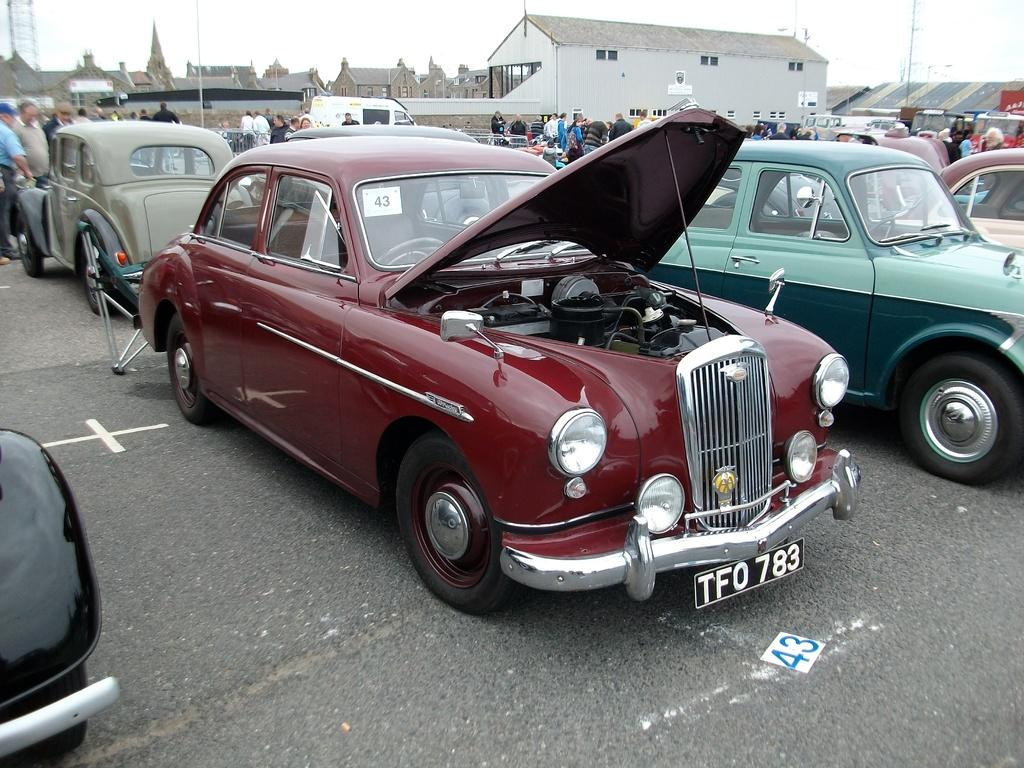What type of vehicles can be seen in the image? There are cars in the image. Who or what else is present in the image? There are persons in the image. What structures are visible at the top of the image? There are shelter houses at the top of the image. What type of wing can be seen on the cars in the image? There are no wings present on the cars in the image; they are regular automobiles. 